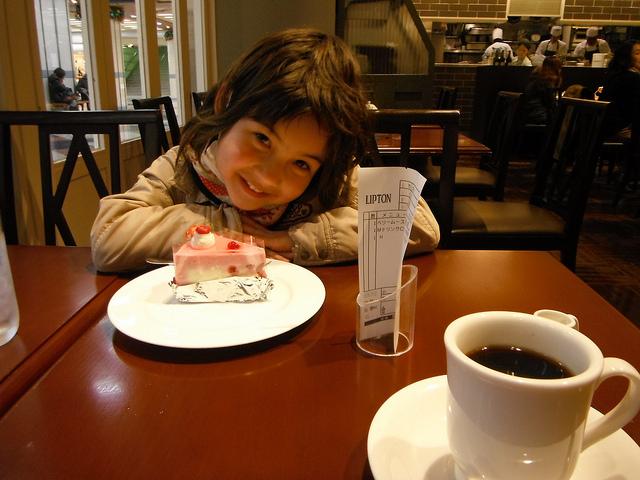Who is the kid looking at?
Be succinct. Photographer. Is this child at home?
Keep it brief. No. What is in the mug?
Answer briefly. Coffee. 